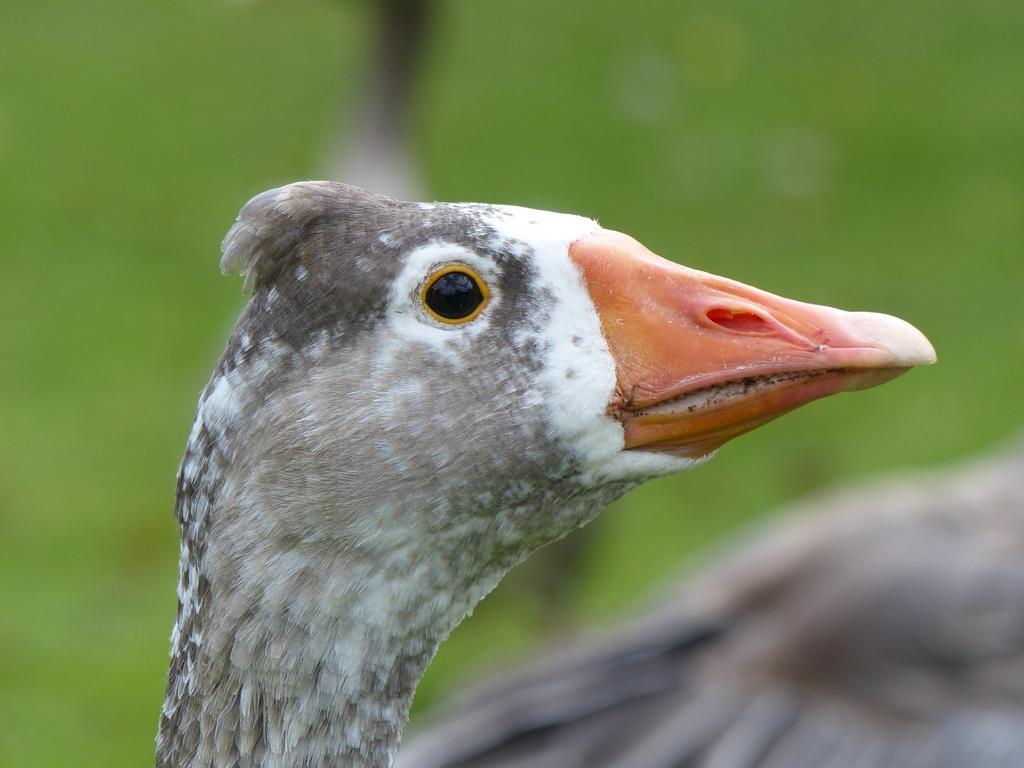How would you summarize this image in a sentence or two? In this image I can see a white and grey colour bird in the front. I can also see green colour in the background and I can see this image is little bit blurry. 